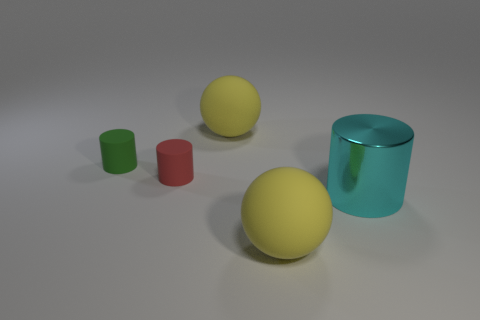What kind of lighting is present in the scene, and what shadows do you notice? The lighting appears to be coming from above, casting soft shadows beneath and to the sides of the objects, which indicates a diffuse light source in the environment. 